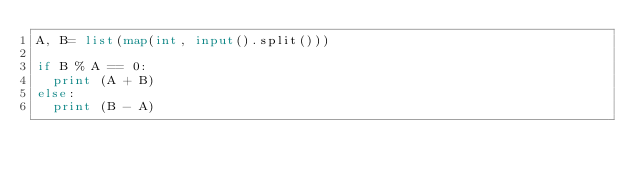<code> <loc_0><loc_0><loc_500><loc_500><_Python_>A, B= list(map(int, input().split()))

if B % A == 0:
  print (A + B)
else:
  print (B - A)</code> 